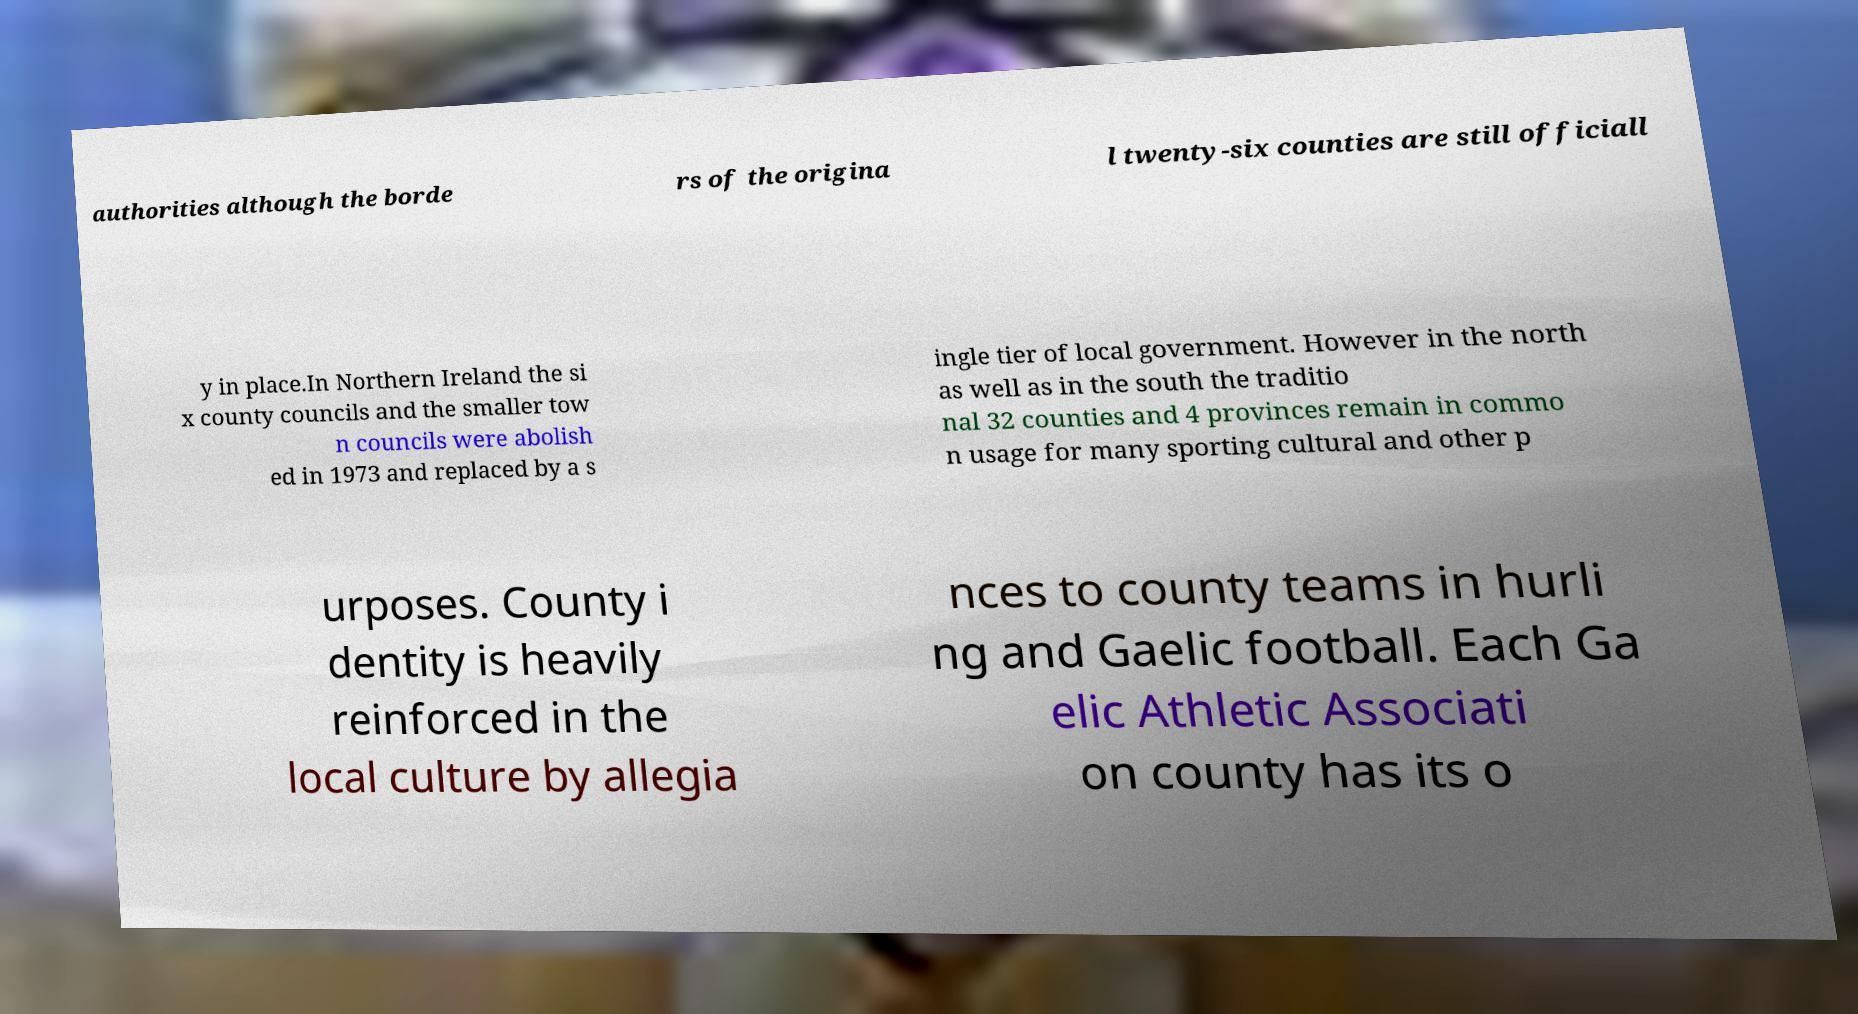Could you extract and type out the text from this image? authorities although the borde rs of the origina l twenty-six counties are still officiall y in place.In Northern Ireland the si x county councils and the smaller tow n councils were abolish ed in 1973 and replaced by a s ingle tier of local government. However in the north as well as in the south the traditio nal 32 counties and 4 provinces remain in commo n usage for many sporting cultural and other p urposes. County i dentity is heavily reinforced in the local culture by allegia nces to county teams in hurli ng and Gaelic football. Each Ga elic Athletic Associati on county has its o 